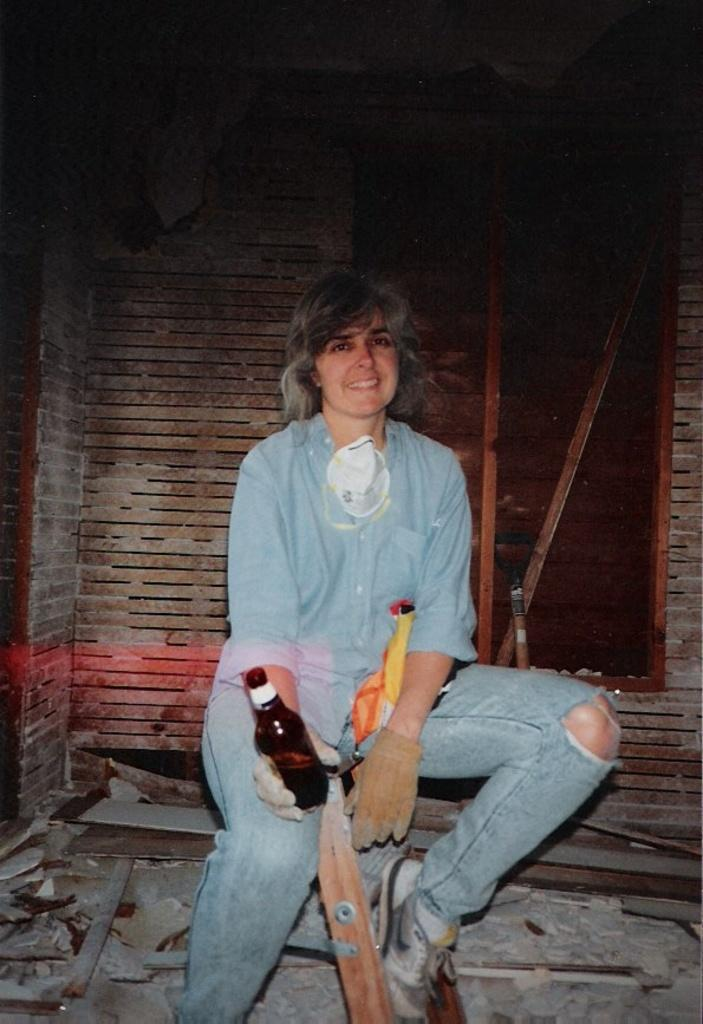What is the main subject of the image? There is a woman in the image. What is the woman holding in the image? The woman is holding a glass. What can be seen in the background of the image? There is a wall visible in the image. How many feet does the secretary have in the image? There is no secretary present in the image, and therefore no feet to count. 